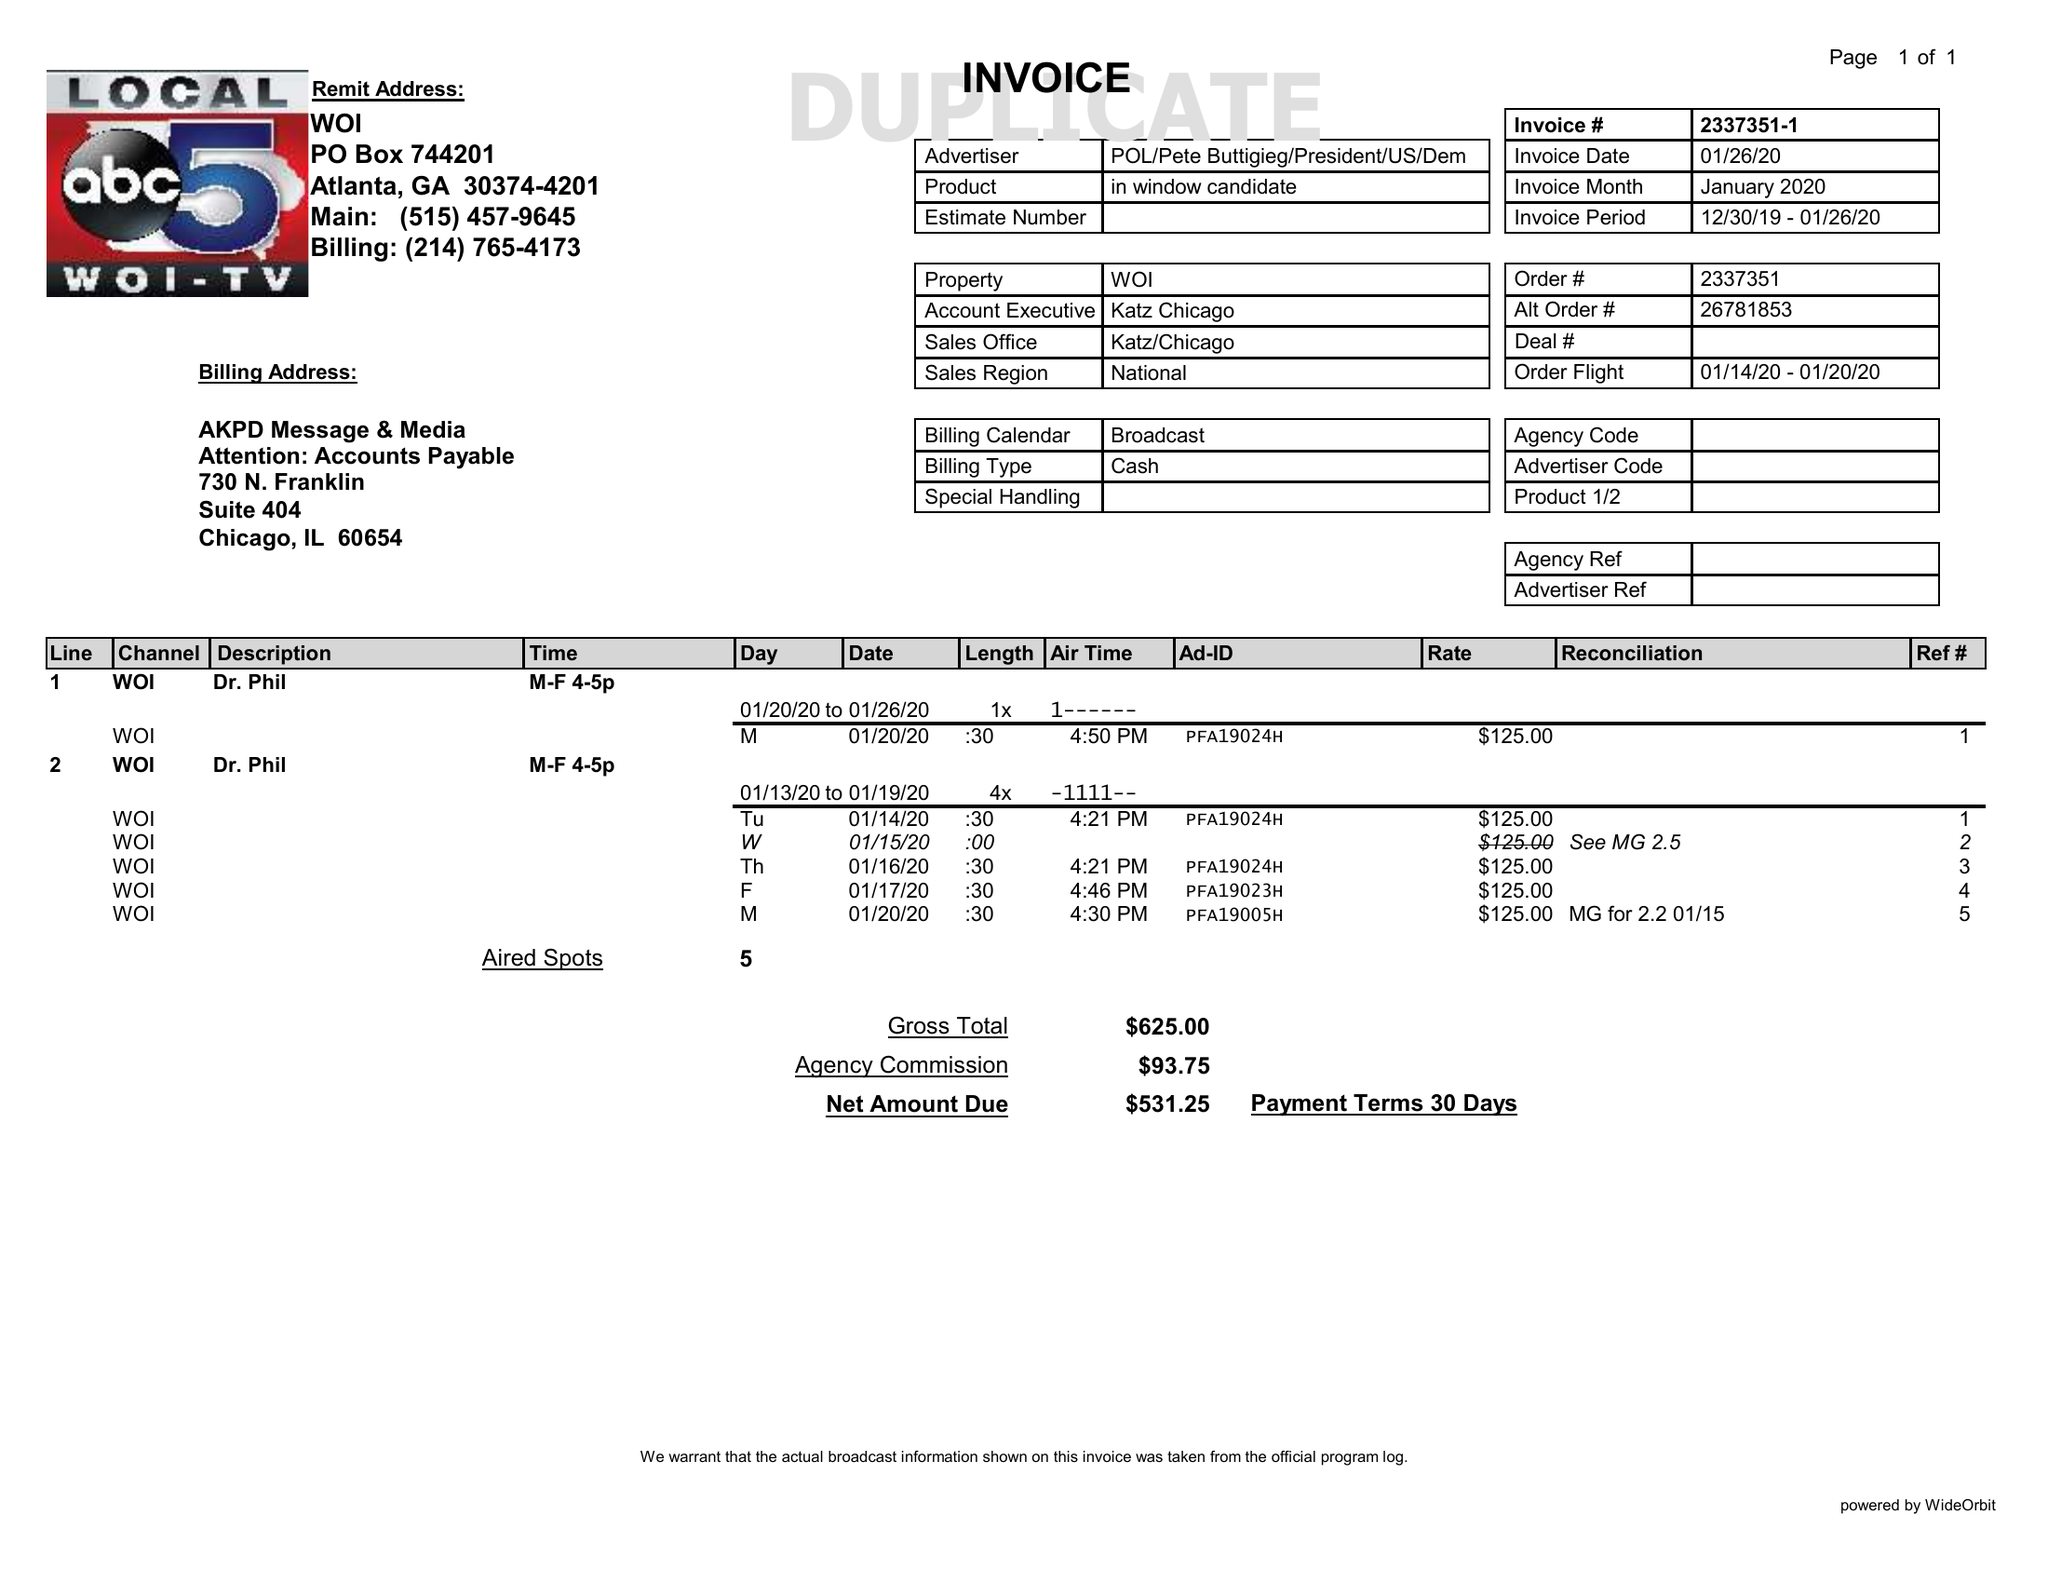What is the value for the advertiser?
Answer the question using a single word or phrase. POL/PETEBUTTIGIEG/PRESIDENT/US/DEM 